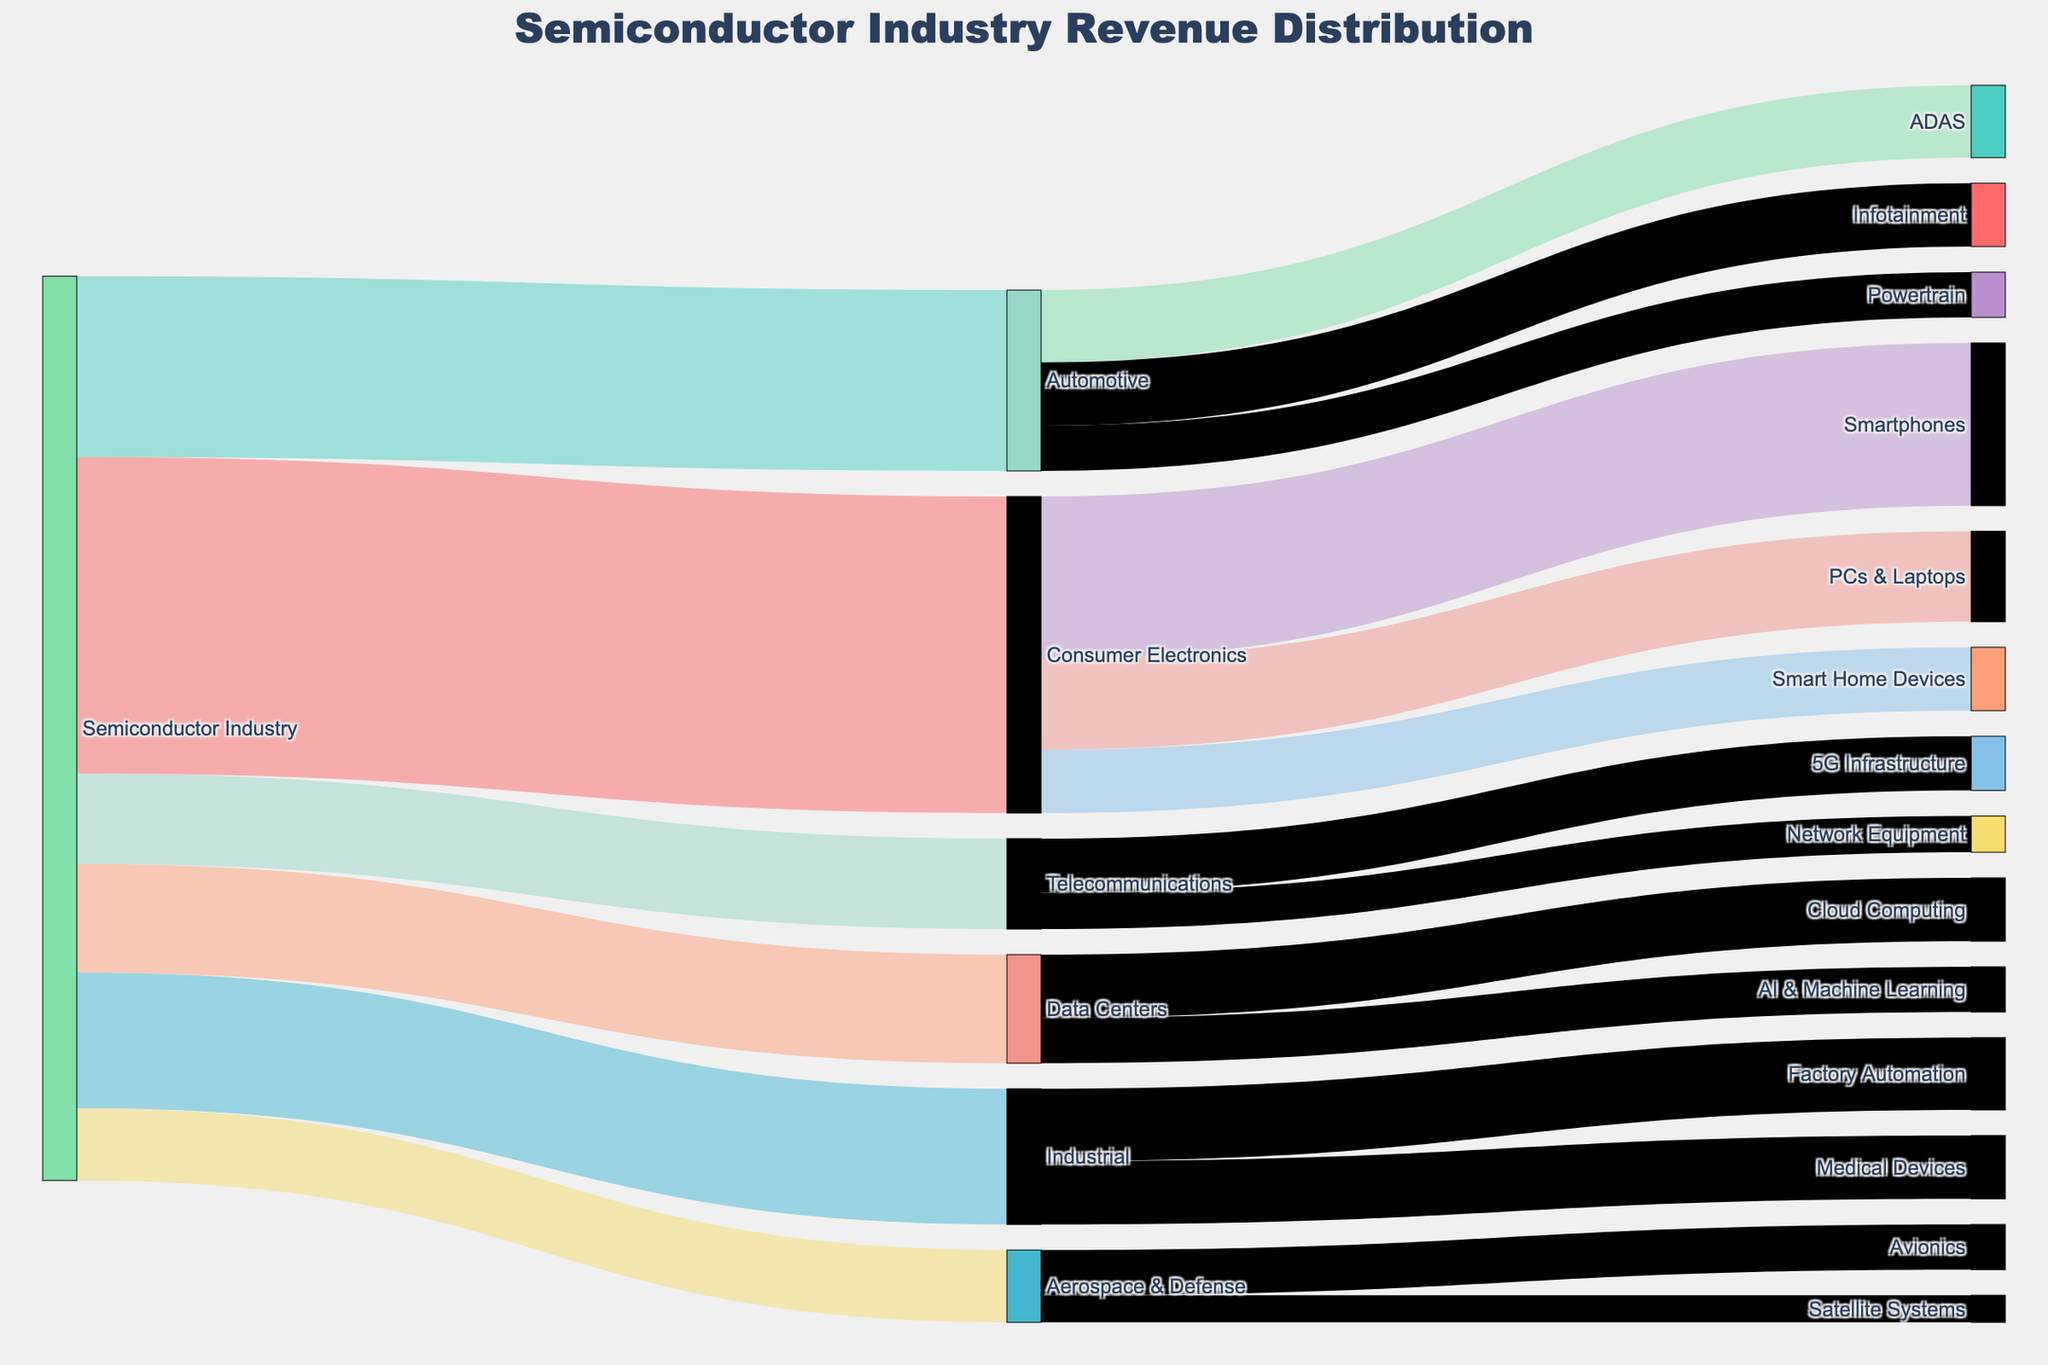How much revenue is attributed to the Consumer Electronics sector? The Sankey diagram shows that the Semiconductor Industry flows to various sectors and the Consumer Electronics sector is allocated 35 units of revenue.
Answer: 35 Which sector receives the least amount of revenue from the Semiconductor Industry? In the Sankey diagram, we observe the revenue distribution from the Semiconductor Industry to various sectors. Aerospace & Defense has the lowest value, receiving only 8 units of revenue.
Answer: Aerospace & Defense What is the total revenue attributed to the Automotive sub-categories? The total revenue for the Automotive sub-categories can be calculated by summing up the values for ADAS (8), Infotainment (7), and Powertrain (5). Therefore, 8 + 7 + 5 = 20.
Answer: 20 Which Consumer Electronics sub-category receives the most revenue? By examining the Consumer Electronics flow, we see it splits into three sub-categories: Smartphones (18), PCs & Laptops (10), and Smart Home Devices (7). From these, Smartphones receives the most revenue with 18 units.
Answer: Smartphones How does the revenue for Factory Automation in the Industrial sector compare to that of Medical Devices? In Industrial sector, Factory Automation is allocated 8 units of revenue, while Medical Devices are allocated 7 units. Therefore, Factory Automation receives more revenue (8 vs. 7).
Answer: Factory Automation What is the total revenue distributed to all application sectors from the Semiconductor Industry? To find the total, add the revenue of all sectors: Consumer Electronics (35), Automotive (20), Industrial (15), Data Centers (12), Telecommunications (10), and Aerospace & Defense (8). So, 35 + 20 + 15 + 12 + 10 + 8 = 100 units.
Answer: 100 Is the revenue allocated to ADAS greater than that for Avionics? ADAS under Automotive receives 8 units of revenue, while Avionics under Aerospace & Defense receives 5 units of revenue. Thus, ADAS receives more revenue than Avionics.
Answer: Yes What percentage of the Semiconductor Industry’s revenue is attributed to Data Centers and its sub-categories? First, determine the total revenue allocated to Data Centers (12 units), then calculate the percentage relative to the total industry revenue (100 units). (12/100) × 100% = 12%.
Answer: 12% Which sub-category under Data Centers has more revenue, Cloud Computing or AI & Machine Learning? For Data Centers, Cloud Computing is attributed 7 units of revenue and AI & Machine Learning is attributed 5 units. Comparing these, Cloud Computing has more revenue than AI & Machine Learning.
Answer: Cloud Computing 